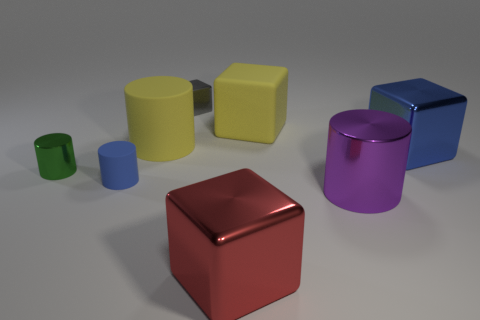Subtract all red cubes. How many cubes are left? 3 Add 1 yellow matte cubes. How many objects exist? 9 Subtract all gray cubes. How many cubes are left? 3 Subtract 1 cubes. How many cubes are left? 3 Subtract 1 blue blocks. How many objects are left? 7 Subtract all cyan cubes. Subtract all blue cylinders. How many cubes are left? 4 Subtract all brown cubes. How many green cylinders are left? 1 Subtract all large purple metal things. Subtract all big red blocks. How many objects are left? 6 Add 6 large metal cubes. How many large metal cubes are left? 8 Add 7 tiny brown objects. How many tiny brown objects exist? 7 